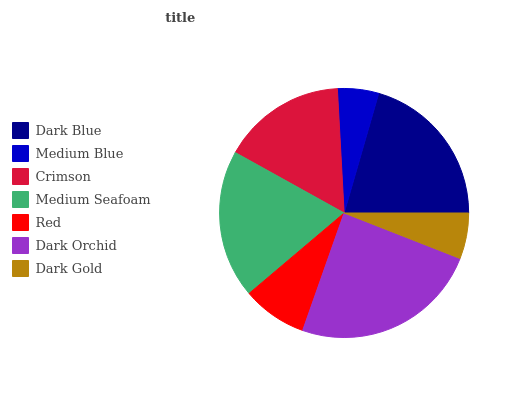Is Medium Blue the minimum?
Answer yes or no. Yes. Is Dark Orchid the maximum?
Answer yes or no. Yes. Is Crimson the minimum?
Answer yes or no. No. Is Crimson the maximum?
Answer yes or no. No. Is Crimson greater than Medium Blue?
Answer yes or no. Yes. Is Medium Blue less than Crimson?
Answer yes or no. Yes. Is Medium Blue greater than Crimson?
Answer yes or no. No. Is Crimson less than Medium Blue?
Answer yes or no. No. Is Crimson the high median?
Answer yes or no. Yes. Is Crimson the low median?
Answer yes or no. Yes. Is Medium Blue the high median?
Answer yes or no. No. Is Dark Gold the low median?
Answer yes or no. No. 